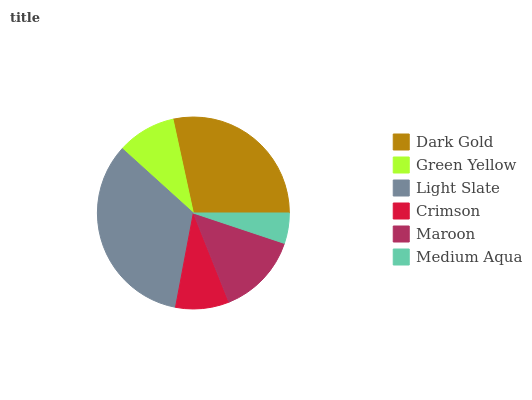Is Medium Aqua the minimum?
Answer yes or no. Yes. Is Light Slate the maximum?
Answer yes or no. Yes. Is Green Yellow the minimum?
Answer yes or no. No. Is Green Yellow the maximum?
Answer yes or no. No. Is Dark Gold greater than Green Yellow?
Answer yes or no. Yes. Is Green Yellow less than Dark Gold?
Answer yes or no. Yes. Is Green Yellow greater than Dark Gold?
Answer yes or no. No. Is Dark Gold less than Green Yellow?
Answer yes or no. No. Is Maroon the high median?
Answer yes or no. Yes. Is Green Yellow the low median?
Answer yes or no. Yes. Is Green Yellow the high median?
Answer yes or no. No. Is Maroon the low median?
Answer yes or no. No. 